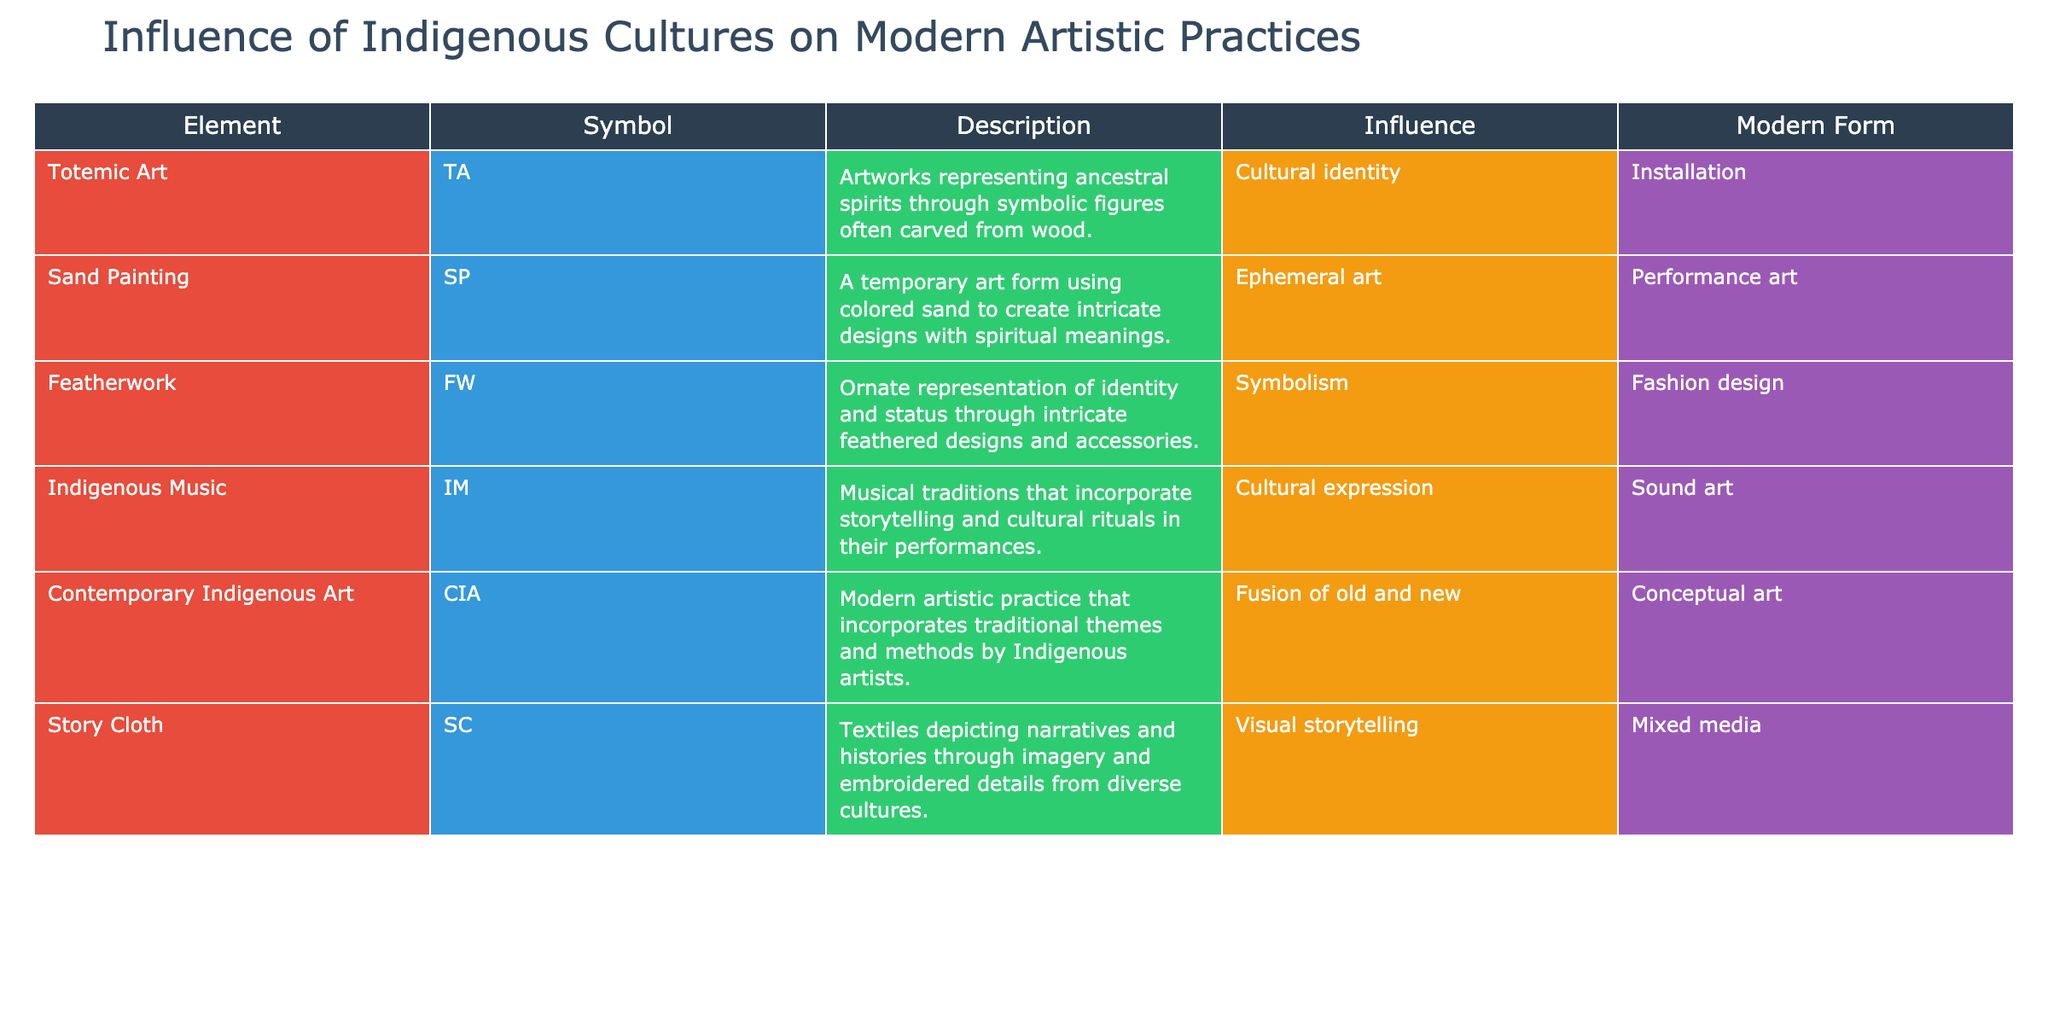What modern form is associated with Totemic Art? According to the table, Totemic Art is associated with the modern form of Installation. This direct correlation can be found in the "Modern Form" column corresponding to the "Element" of Totemic Art.
Answer: Installation Which art form is categorized as Ephemeral art? From the information provided, Sand Painting is categorized as Ephemeral art. This can be located in the "Influence" column of the row for Sand Painting.
Answer: Ephemeral art True or False: Featherwork is primarily represented through architectural designs. The table clearly states that Featherwork represents identity and status through intricate feathered designs, not architectural designs. Therefore, this statement is false.
Answer: False What is the main influence of contemporary Indigenous art? The table reveals that the main influence of Contemporary Indigenous Art is the fusion of old and new. This influence is mentioned in the "Influence" column for the Contemporary Indigenous Art row.
Answer: Fusion of old and new Which art forms are linked to the modern form of Mixed media? The table indicates that the Story Cloth is linked to the modern form of Mixed media. This information is directly taken from the "Modern Form" column specifically for Story Cloth.
Answer: Story Cloth How many artistic practices listed are associated with Cultural expression? By reviewing the "Influence" column, we see that Indigenous Music is the only artistic practice associated with Cultural expression, which makes it one. Therefore, the count is 1.
Answer: 1 True or False: Sand Painting utilizes permanent materials for its designs. The nature of Sand Painting as described in the table emphasizes its temporariness due to the use of colored sand, implying that it does not employ permanent materials. Thus, this statement is false.
Answer: False What is the common bond between Indigenous Music and Featherwork regarding modern artistic expression? Both Indigenous Music and Featherwork stem from a basis of cultural identity. Specifically, Indigenous Music connects through cultural expression while Featherwork exemplifies symbolism, indicating a shared heritage and cultural connection in modern artistic practices.
Answer: Cultural identity How does the influence of Indigenous cultures manifest in the modern form of Fashion design? According to the table, Featherwork manifests the influence of Indigenous cultures through Fashion design. This is detailed in the "Modern Form" for Featherwork, showcasing how traditional practices continue into contemporary fashion.
Answer: Fashion design 